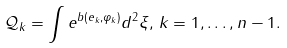<formula> <loc_0><loc_0><loc_500><loc_500>\mathcal { Q } _ { k } = \int e ^ { b ( e _ { k } , \varphi _ { k } ) } d ^ { 2 } \xi , \, k = 1 , \dots , n - 1 .</formula> 